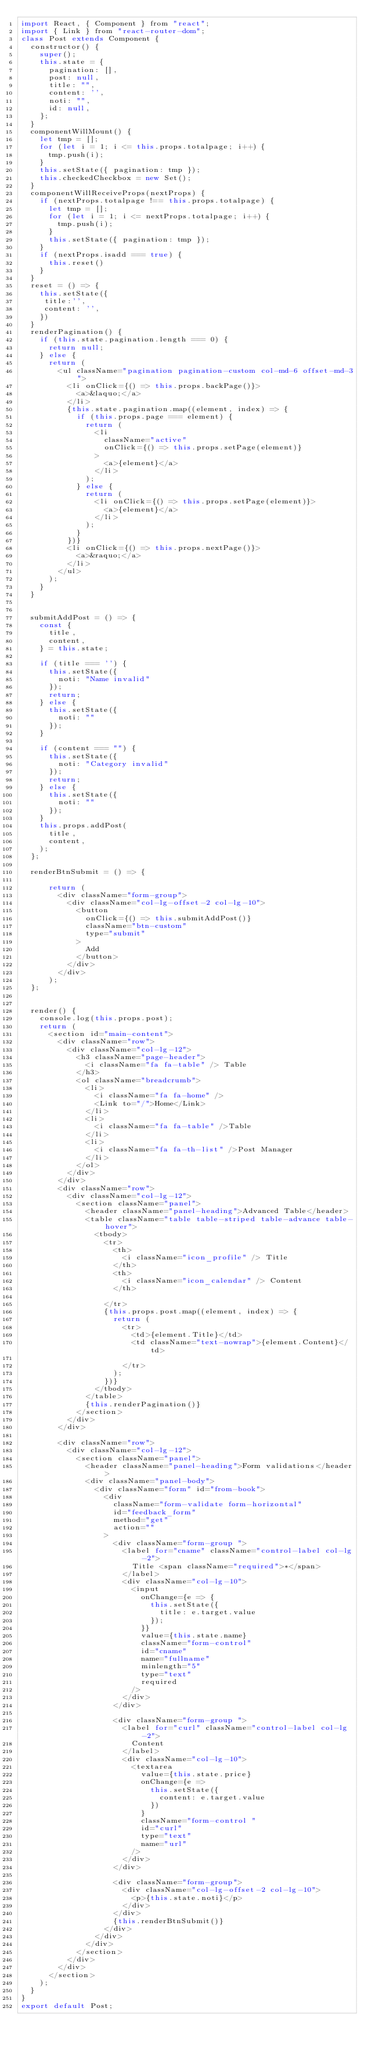<code> <loc_0><loc_0><loc_500><loc_500><_JavaScript_>import React, { Component } from "react";
import { Link } from "react-router-dom";
class Post extends Component {
  constructor() {
    super();
    this.state = {
      pagination: [],
      post: null,
      title: "",
      content: '',
      noti: "",
      id: null,
    };
  }
  componentWillMount() {
    let tmp = [];
    for (let i = 1; i <= this.props.totalpage; i++) {
      tmp.push(i);
    }
    this.setState({ pagination: tmp });
    this.checkedCheckbox = new Set();
  }
  componentWillReceiveProps(nextProps) {
    if (nextProps.totalpage !== this.props.totalpage) {
      let tmp = [];
      for (let i = 1; i <= nextProps.totalpage; i++) {
        tmp.push(i);
      }
      this.setState({ pagination: tmp });
    }
    if (nextProps.isadd === true) {
      this.reset()
    } 
  }
  reset = () => {
    this.setState({
     title:'',
     content: '',
    })
  }
  renderPagination() {
    if (this.state.pagination.length === 0) {
      return null;
    } else {
      return (
        <ul className="pagination pagination-custom col-md-6 offset-md-3">
          <li onClick={() => this.props.backPage()}>
            <a>&laquo;</a>
          </li>
          {this.state.pagination.map((element, index) => {
            if (this.props.page === element) {
              return (
                <li
                  className="active"
                  onClick={() => this.props.setPage(element)}
                >
                  <a>{element}</a>
                </li>
              );
            } else {
              return (
                <li onClick={() => this.props.setPage(element)}>
                  <a>{element}</a>
                </li>
              );
            }
          })}
          <li onClick={() => this.props.nextPage()}>
            <a>&raquo;</a>
          </li>
        </ul>
      );
    }
  }
  
  
  submitAddPost = () => {
    const {
      title,
      content,
    } = this.state;

    if (title === '') {
      this.setState({
        noti: "Name invalid"
      });
      return;
    } else {
      this.setState({
        noti: ""
      });
    }
    
    if (content === "") {
      this.setState({
        noti: "Category invalid"
      });
      return;
    } else {
      this.setState({
        noti: ""
      });
    }
    this.props.addPost(
      title,
      content,
    );
  };

  renderBtnSubmit = () => {
    
      return (
        <div className="form-group">
          <div className="col-lg-offset-2 col-lg-10">
            <button
              onClick={() => this.submitAddPost()}
              className="btn-custom"
              type="submit"
            >
              Add
            </button>
          </div>
        </div>
      );
  };
 

  render() {
    console.log(this.props.post);
    return (
      <section id="main-content">
        <div className="row">
          <div className="col-lg-12">
            <h3 className="page-header">
              <i className="fa fa-table" /> Table
            </h3>
            <ol className="breadcrumb">
              <li>
                <i className="fa fa-home" />
                <Link to="/">Home</Link>
              </li>
              <li>
                <i className="fa fa-table" />Table
              </li>
              <li>
                <i className="fa fa-th-list" />Post Manager
              </li>
            </ol>
          </div>
        </div>
        <div className="row">
          <div className="col-lg-12">
            <section className="panel">
              <header className="panel-heading">Advanced Table</header>
              <table className="table table-striped table-advance table-hover">
                <tbody>
                  <tr>
                    <th>
                      <i className="icon_profile" /> Title
                    </th>
                    <th>
                      <i className="icon_calendar" /> Content
                    </th>
                   
                  </tr>
                  {this.props.post.map((element, index) => {
                    return (
                      <tr>
                        <td>{element.Title}</td>
                        <td className="text-nowrap">{element.Content}</td>

                      </tr>
                    );
                  })}
                </tbody>
              </table>
              {this.renderPagination()}
            </section>
          </div>
        </div>

        <div className="row">
          <div className="col-lg-12">
            <section className="panel">
              <header className="panel-heading">Form validations</header>
              <div className="panel-body">
                <div className="form" id="from-book">
                  <div
                    className="form-validate form-horizontal"
                    id="feedback_form"
                    method="get"
                    action=""
                  >
                    <div className="form-group ">
                      <label for="cname" className="control-label col-lg-2">
                        Title <span className="required">*</span>
                      </label>
                      <div className="col-lg-10">
                        <input
                          onChange={e => {
                            this.setState({
                              title: e.target.value
                            });
                          }}
                          value={this.state.name}
                          className="form-control"
                          id="cname"
                          name="fullname"
                          minlength="5"
                          type="text"
                          required
                        />
                      </div>
                    </div>
                 
                    <div className="form-group ">
                      <label for="curl" className="control-label col-lg-2">
                        Content
                      </label>
                      <div className="col-lg-10">
                        <textarea
                          value={this.state.price}
                          onChange={e =>
                            this.setState({
                              content: e.target.value
                            })
                          }
                          className="form-control "
                          id="curl"
                          type="text"
                          name="url"
                        />
                      </div>
                    </div>
                    
                    <div className="form-group">
                      <div className="col-lg-offset-2 col-lg-10">
                        <p>{this.state.noti}</p>
                      </div>
                    </div>
                    {this.renderBtnSubmit()}
                  </div>
                </div>
              </div>
            </section>
          </div>
        </div>
      </section>
    );
  }
}
export default Post;
</code> 